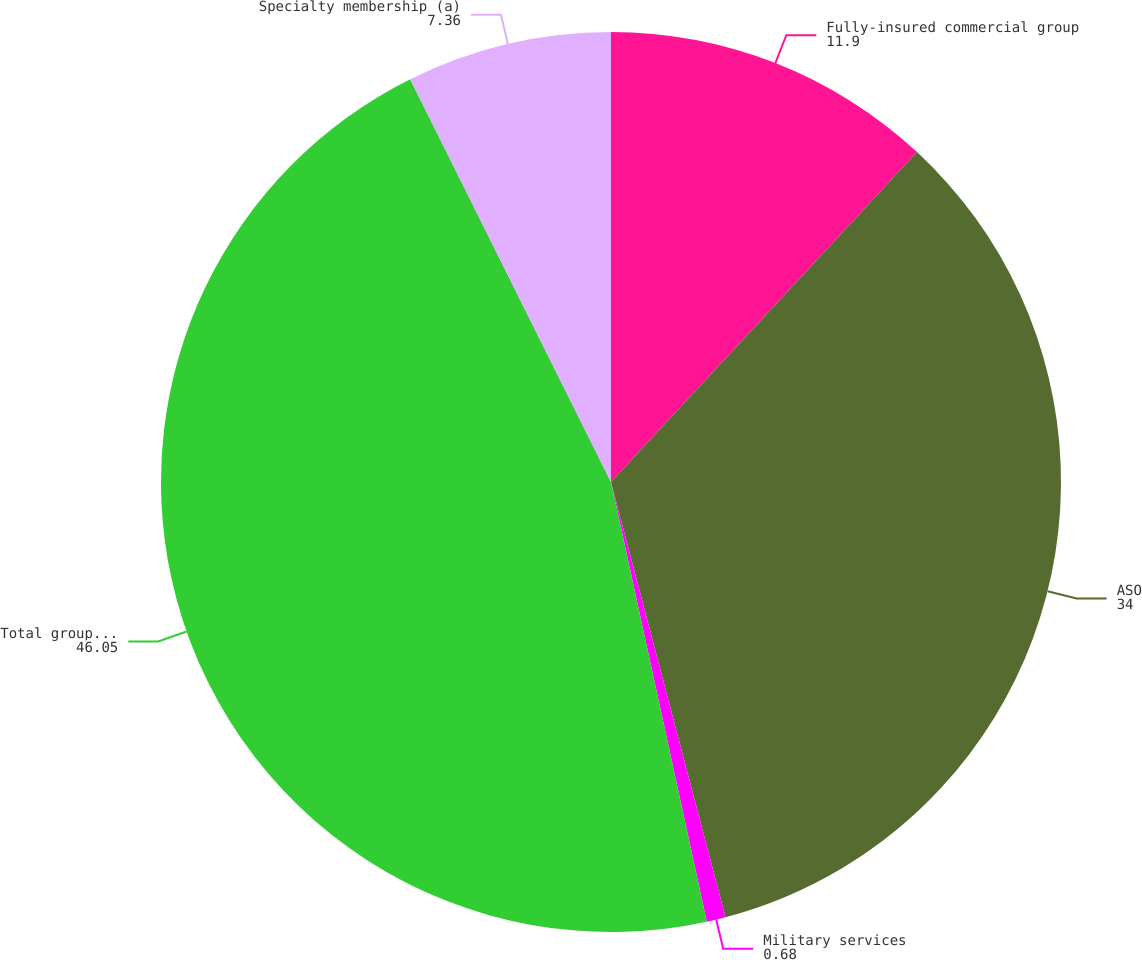<chart> <loc_0><loc_0><loc_500><loc_500><pie_chart><fcel>Fully-insured commercial group<fcel>ASO<fcel>Military services<fcel>Total group medical members<fcel>Specialty membership (a)<nl><fcel>11.9%<fcel>34.0%<fcel>0.68%<fcel>46.05%<fcel>7.36%<nl></chart> 